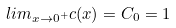<formula> <loc_0><loc_0><loc_500><loc_500>l i m _ { x \rightarrow 0 ^ { + } } c ( x ) = C _ { 0 } = 1</formula> 